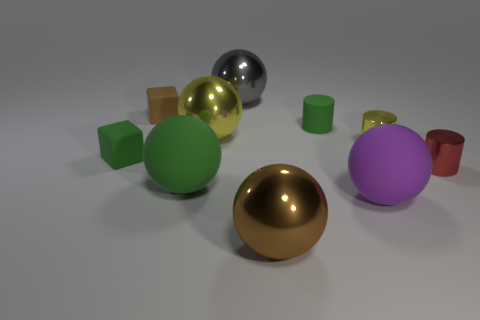How many rubber objects are small green blocks or large green things?
Keep it short and to the point. 2. Is the green ball the same size as the green matte block?
Give a very brief answer. No. Is the number of brown balls behind the small green block less than the number of yellow objects on the left side of the big brown thing?
Give a very brief answer. Yes. How big is the red cylinder?
Your response must be concise. Small. What number of small objects are either purple rubber things or yellow metallic spheres?
Your answer should be very brief. 0. There is a gray shiny ball; does it have the same size as the cylinder on the right side of the small yellow metallic cylinder?
Ensure brevity in your answer.  No. Are there any other things that are the same shape as the gray object?
Offer a terse response. Yes. What number of shiny spheres are there?
Offer a very short reply. 3. What number of yellow things are either rubber cubes or metallic things?
Offer a very short reply. 2. Does the yellow thing that is left of the gray metallic ball have the same material as the small green cylinder?
Provide a short and direct response. No. 